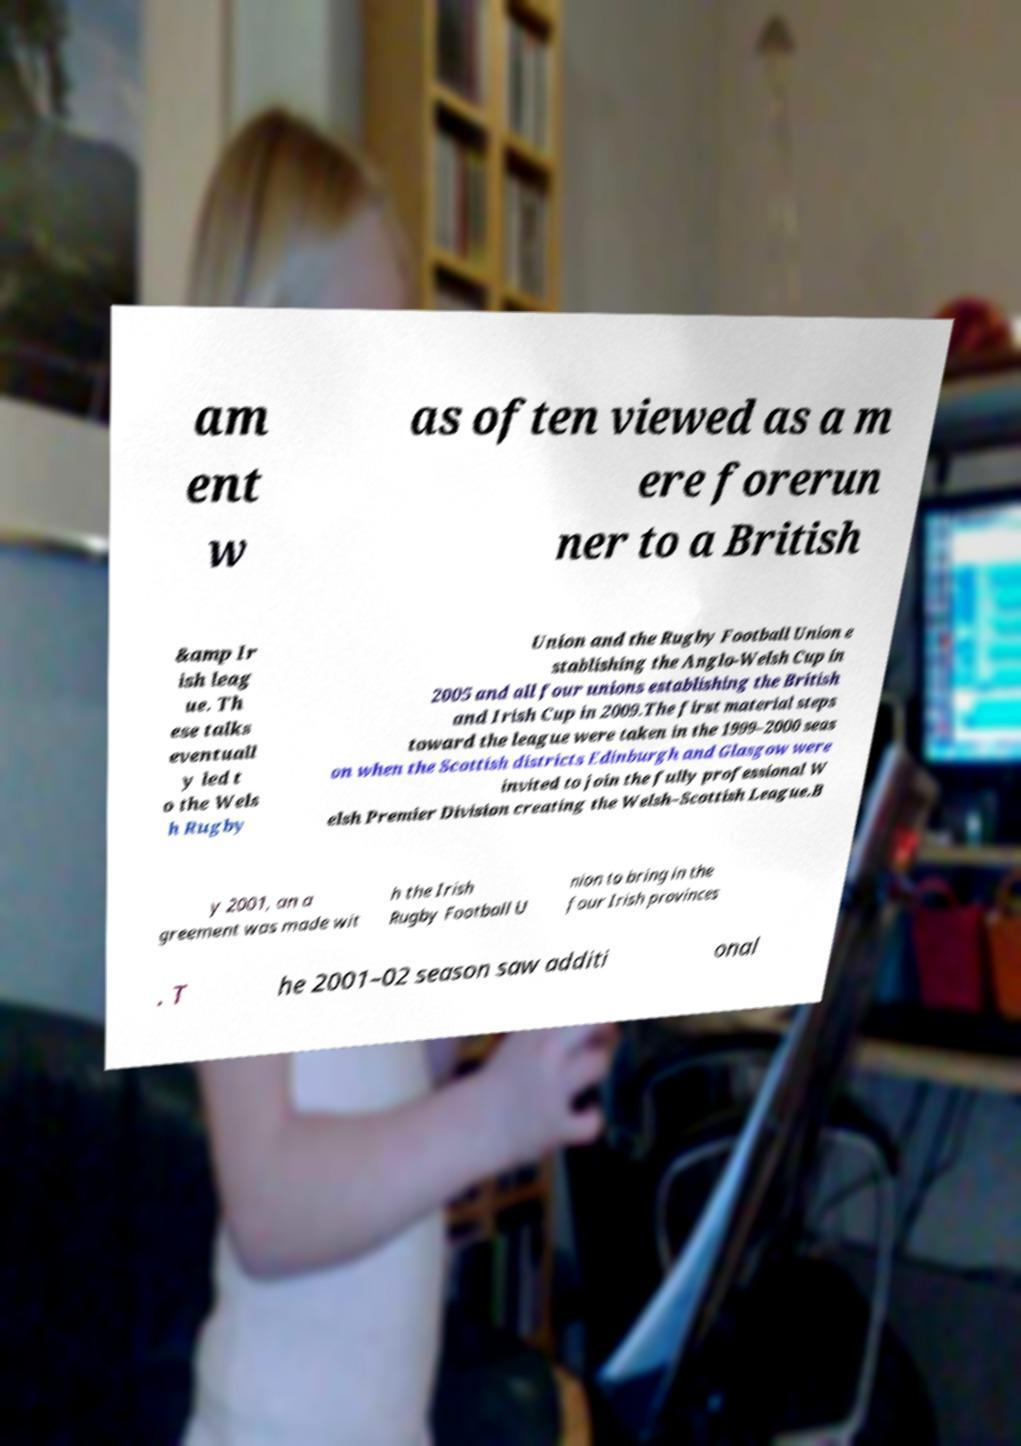Could you extract and type out the text from this image? am ent w as often viewed as a m ere forerun ner to a British &amp Ir ish leag ue. Th ese talks eventuall y led t o the Wels h Rugby Union and the Rugby Football Union e stablishing the Anglo-Welsh Cup in 2005 and all four unions establishing the British and Irish Cup in 2009.The first material steps toward the league were taken in the 1999–2000 seas on when the Scottish districts Edinburgh and Glasgow were invited to join the fully professional W elsh Premier Division creating the Welsh–Scottish League.B y 2001, an a greement was made wit h the Irish Rugby Football U nion to bring in the four Irish provinces . T he 2001–02 season saw additi onal 